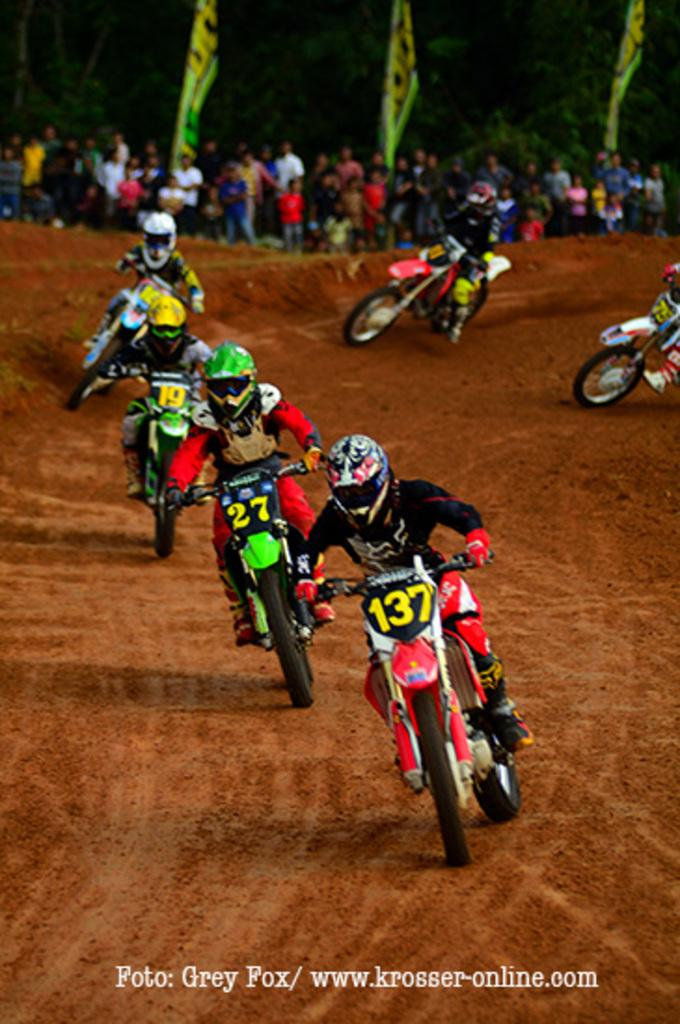What is happening in the image involving a group of people? There is a group of people standing in the image. What can be seen in the background of the image? There are many trees in the image. How many flags are visible in the image? There are three flags in the image. What activity are some people engaged in within the image? There are people riding bikes in the image. What type of ring is being used to teach the people riding bikes in the image? There is no ring present in the image, nor is anyone teaching the people riding bikes. What kind of brush is being used to clean the trees in the image? There is no brush present in the image, and the trees are not being cleaned. 